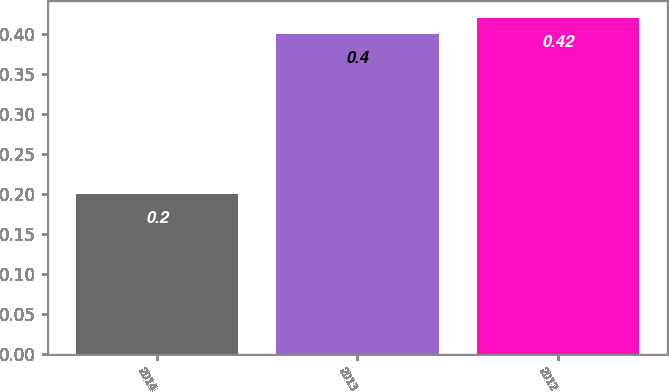Convert chart to OTSL. <chart><loc_0><loc_0><loc_500><loc_500><bar_chart><fcel>2014<fcel>2013<fcel>2012<nl><fcel>0.2<fcel>0.4<fcel>0.42<nl></chart> 